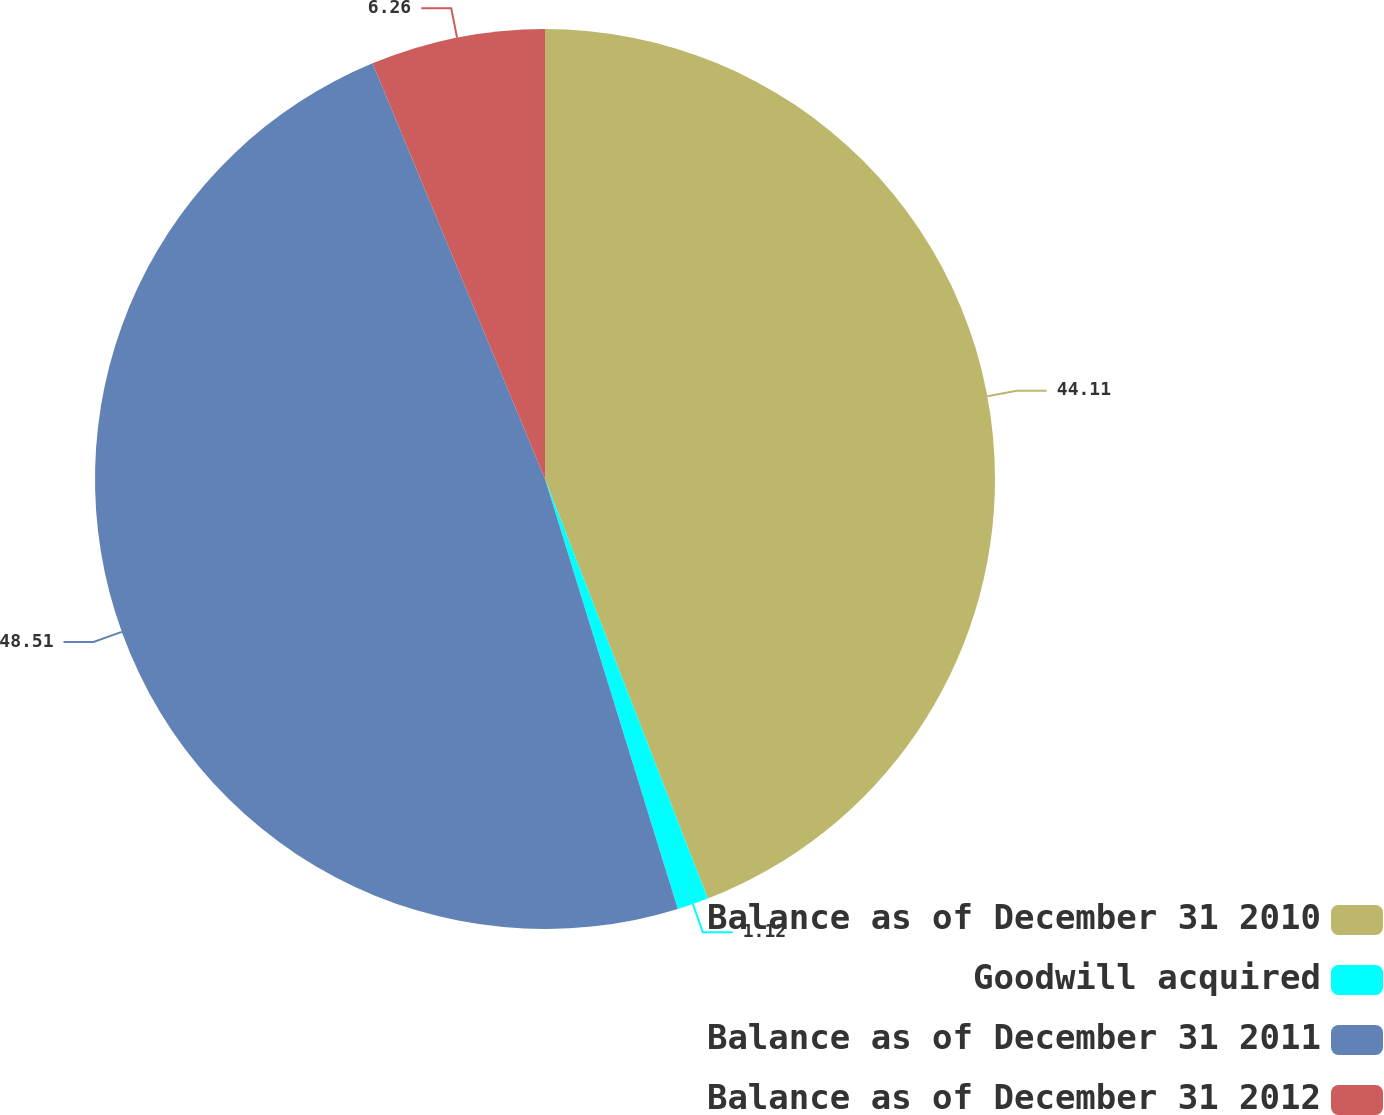Convert chart. <chart><loc_0><loc_0><loc_500><loc_500><pie_chart><fcel>Balance as of December 31 2010<fcel>Goodwill acquired<fcel>Balance as of December 31 2011<fcel>Balance as of December 31 2012<nl><fcel>44.11%<fcel>1.12%<fcel>48.51%<fcel>6.26%<nl></chart> 